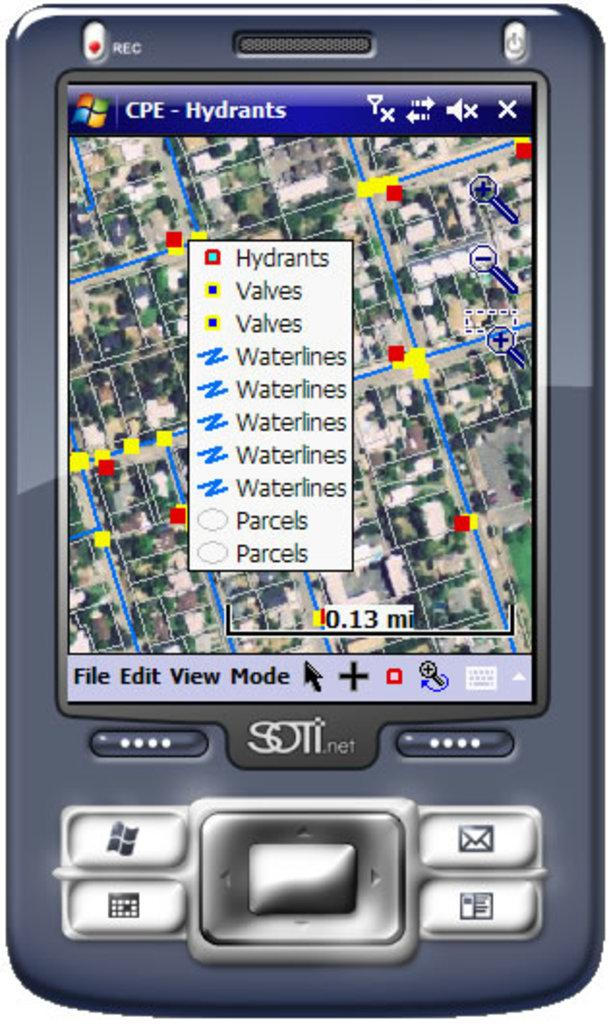<image>
Give a short and clear explanation of the subsequent image. A phone screen showing the locations of Waterlines and hydrants 